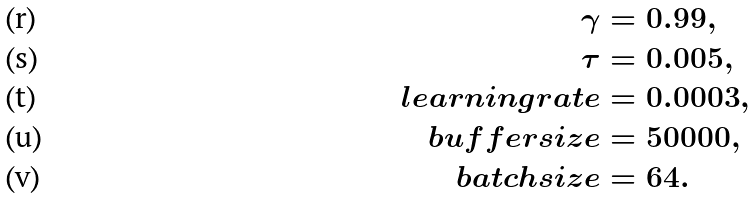<formula> <loc_0><loc_0><loc_500><loc_500>\gamma & = 0 . 9 9 , \\ \tau & = 0 . 0 0 5 , \\ l e a r n i n g r a t e & = 0 . 0 0 0 3 , \\ b u f f e r s i z e & = 5 0 0 0 0 , \\ b a t c h s i z e & = 6 4 .</formula> 